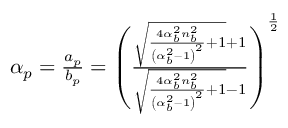<formula> <loc_0><loc_0><loc_500><loc_500>\begin{array} { r } { \alpha _ { p } = \frac { a _ { p } } { b _ { p } } = \left ( \frac { \sqrt { \frac { 4 \alpha _ { b } ^ { 2 } n _ { b } ^ { 2 } } { \left ( \alpha _ { b } ^ { 2 } - 1 \right ) ^ { 2 } } + 1 } + 1 } { \sqrt { \frac { 4 \alpha _ { b } ^ { 2 } n _ { b } ^ { 2 } } { \left ( \alpha _ { b } ^ { 2 } - 1 \right ) ^ { 2 } } + 1 } - 1 } \right ) ^ { \frac { 1 } { 2 } } } \end{array}</formula> 